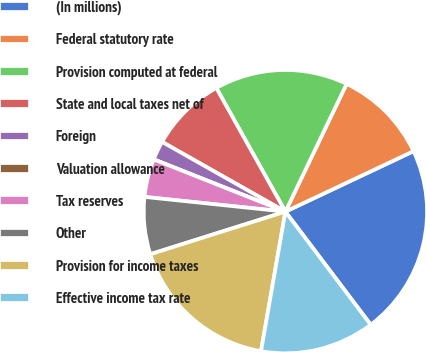Convert chart to OTSL. <chart><loc_0><loc_0><loc_500><loc_500><pie_chart><fcel>(In millions)<fcel>Federal statutory rate<fcel>Provision computed at federal<fcel>State and local taxes net of<fcel>Foreign<fcel>Valuation allowance<fcel>Tax reserves<fcel>Other<fcel>Provision for income taxes<fcel>Effective income tax rate<nl><fcel>21.73%<fcel>10.87%<fcel>15.22%<fcel>8.7%<fcel>2.18%<fcel>0.0%<fcel>4.35%<fcel>6.52%<fcel>17.39%<fcel>13.04%<nl></chart> 